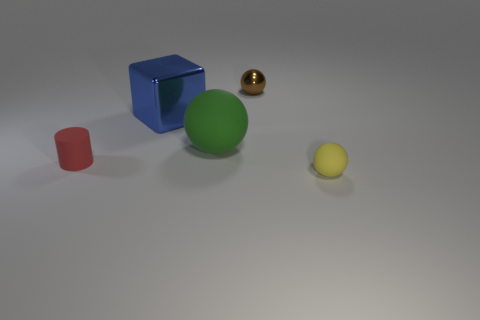How many objects are matte things that are in front of the green matte object or green rubber spheres?
Provide a short and direct response. 3. There is a red cylinder that is the same material as the green sphere; what size is it?
Your answer should be very brief. Small. What number of rubber spheres have the same color as the small metal sphere?
Offer a terse response. 0. How many tiny things are either blue metal blocks or red rubber cylinders?
Keep it short and to the point. 1. Are there any big cyan cylinders that have the same material as the red cylinder?
Offer a very short reply. No. What is the ball behind the shiny block made of?
Provide a succinct answer. Metal. There is a tiny metal ball that is behind the tiny yellow matte object; does it have the same color as the small object that is in front of the cylinder?
Give a very brief answer. No. There is a sphere that is the same size as the brown shiny object; what is its color?
Your answer should be compact. Yellow. What number of other things are the same shape as the green rubber thing?
Ensure brevity in your answer.  2. There is a rubber ball that is on the left side of the small yellow rubber object; how big is it?
Give a very brief answer. Large. 